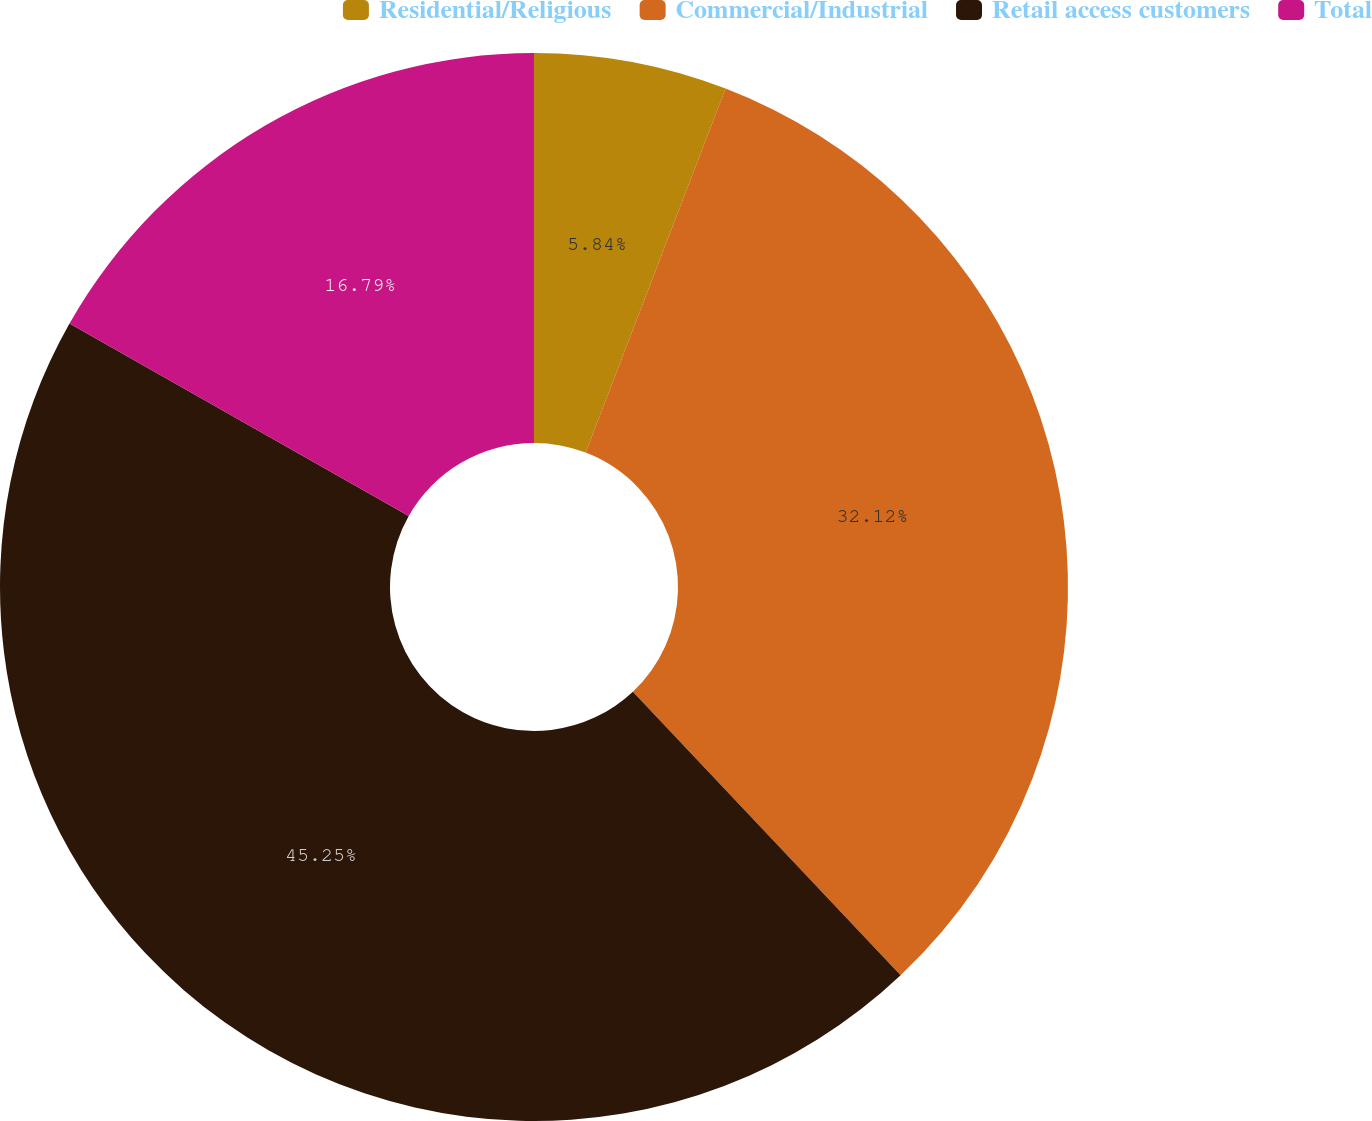<chart> <loc_0><loc_0><loc_500><loc_500><pie_chart><fcel>Residential/Religious<fcel>Commercial/Industrial<fcel>Retail access customers<fcel>Total<nl><fcel>5.84%<fcel>32.12%<fcel>45.26%<fcel>16.79%<nl></chart> 